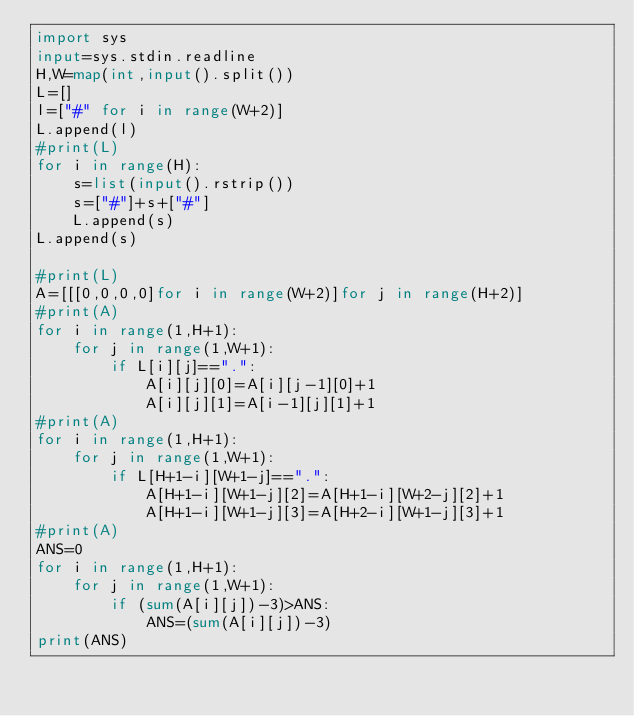<code> <loc_0><loc_0><loc_500><loc_500><_Python_>import sys
input=sys.stdin.readline
H,W=map(int,input().split())
L=[]
l=["#" for i in range(W+2)]
L.append(l)
#print(L)
for i in range(H):
    s=list(input().rstrip())
    s=["#"]+s+["#"]
    L.append(s)
L.append(s)

#print(L)
A=[[[0,0,0,0]for i in range(W+2)]for j in range(H+2)]
#print(A)
for i in range(1,H+1):
    for j in range(1,W+1):
        if L[i][j]==".":
            A[i][j][0]=A[i][j-1][0]+1
            A[i][j][1]=A[i-1][j][1]+1
#print(A)
for i in range(1,H+1):
    for j in range(1,W+1):
        if L[H+1-i][W+1-j]==".":
            A[H+1-i][W+1-j][2]=A[H+1-i][W+2-j][2]+1
            A[H+1-i][W+1-j][3]=A[H+2-i][W+1-j][3]+1
#print(A)
ANS=0
for i in range(1,H+1):
    for j in range(1,W+1):
        if (sum(A[i][j])-3)>ANS:
            ANS=(sum(A[i][j])-3)
print(ANS)</code> 